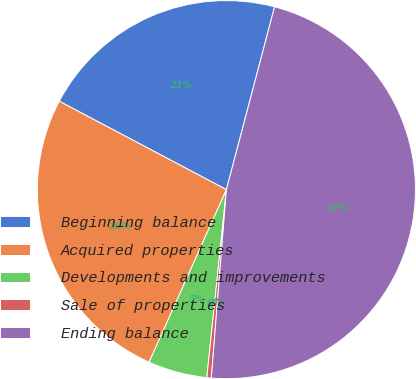Convert chart. <chart><loc_0><loc_0><loc_500><loc_500><pie_chart><fcel>Beginning balance<fcel>Acquired properties<fcel>Developments and improvements<fcel>Sale of properties<fcel>Ending balance<nl><fcel>21.36%<fcel>26.04%<fcel>5.05%<fcel>0.38%<fcel>47.17%<nl></chart> 